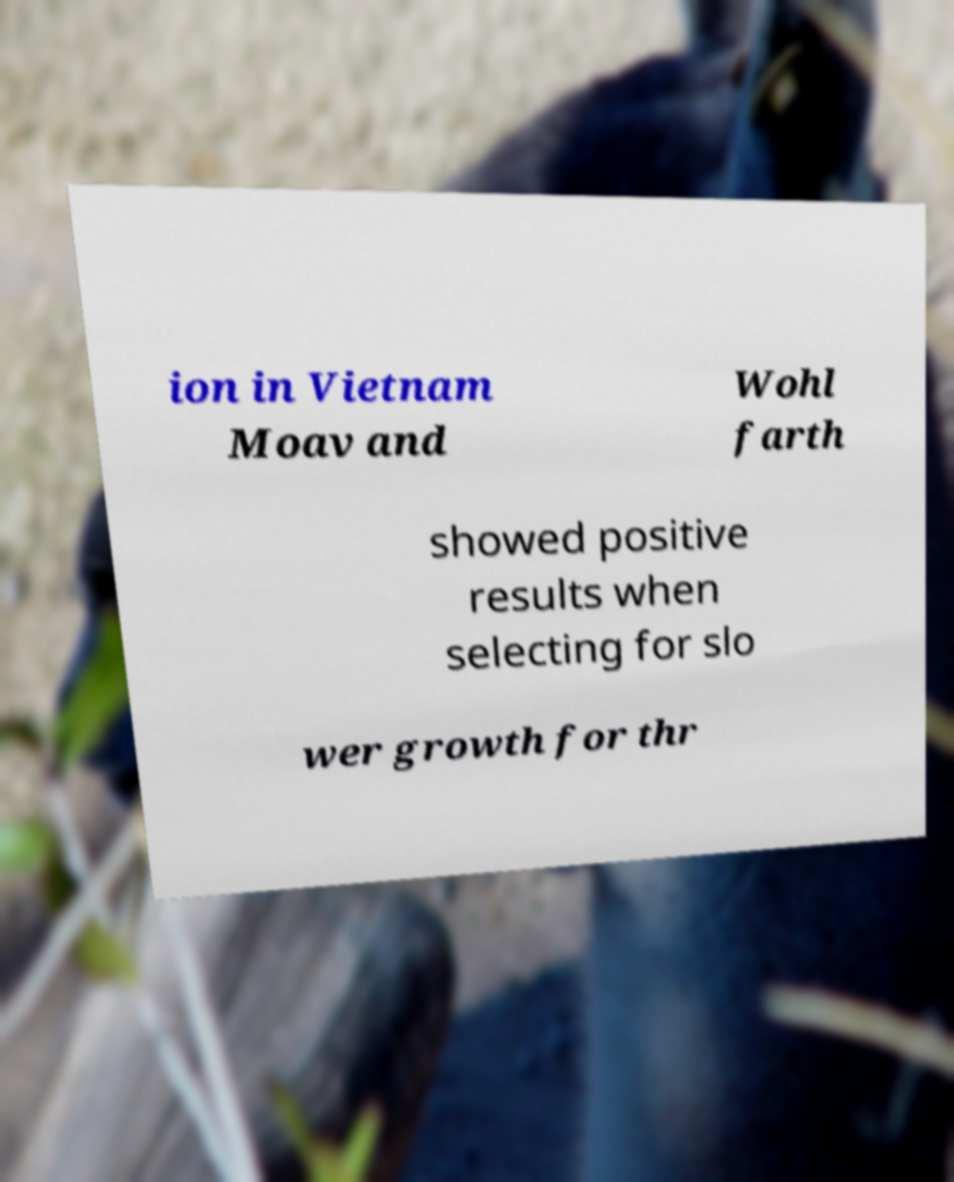Could you extract and type out the text from this image? ion in Vietnam Moav and Wohl farth showed positive results when selecting for slo wer growth for thr 